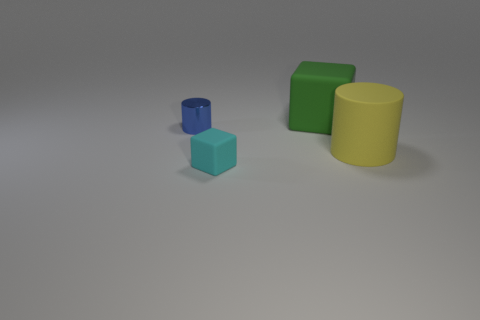Subtract all green blocks. How many blocks are left? 1 Add 2 large green matte things. How many objects exist? 6 Subtract all blue cylinders. Subtract all red blocks. How many cylinders are left? 1 Subtract all blue balls. How many brown cubes are left? 0 Subtract all small purple matte cubes. Subtract all blue cylinders. How many objects are left? 3 Add 3 metallic cylinders. How many metallic cylinders are left? 4 Add 3 green matte objects. How many green matte objects exist? 4 Subtract 0 purple cubes. How many objects are left? 4 Subtract 1 cylinders. How many cylinders are left? 1 